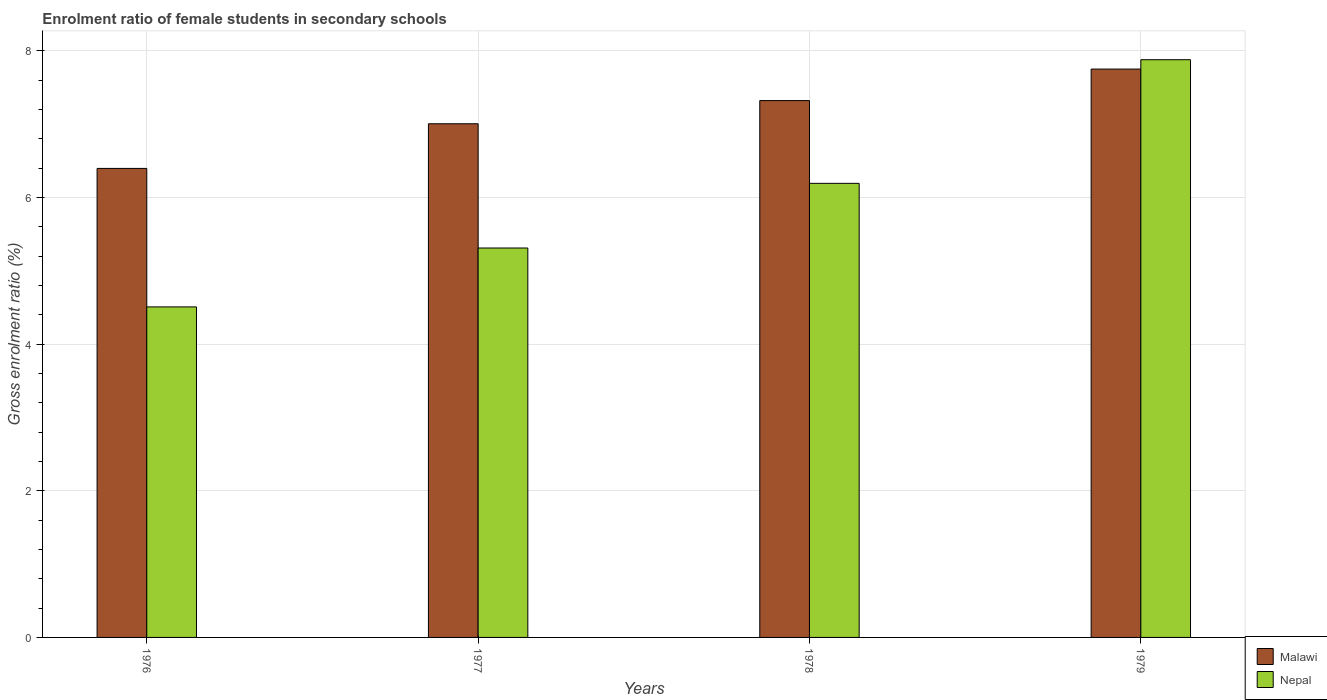How many different coloured bars are there?
Ensure brevity in your answer.  2. Are the number of bars on each tick of the X-axis equal?
Keep it short and to the point. Yes. How many bars are there on the 4th tick from the right?
Make the answer very short. 2. What is the label of the 3rd group of bars from the left?
Offer a very short reply. 1978. In how many cases, is the number of bars for a given year not equal to the number of legend labels?
Provide a short and direct response. 0. What is the enrolment ratio of female students in secondary schools in Nepal in 1978?
Your response must be concise. 6.19. Across all years, what is the maximum enrolment ratio of female students in secondary schools in Nepal?
Provide a succinct answer. 7.88. Across all years, what is the minimum enrolment ratio of female students in secondary schools in Nepal?
Offer a terse response. 4.51. In which year was the enrolment ratio of female students in secondary schools in Malawi maximum?
Ensure brevity in your answer.  1979. In which year was the enrolment ratio of female students in secondary schools in Nepal minimum?
Provide a succinct answer. 1976. What is the total enrolment ratio of female students in secondary schools in Malawi in the graph?
Your response must be concise. 28.48. What is the difference between the enrolment ratio of female students in secondary schools in Malawi in 1976 and that in 1978?
Ensure brevity in your answer.  -0.93. What is the difference between the enrolment ratio of female students in secondary schools in Nepal in 1978 and the enrolment ratio of female students in secondary schools in Malawi in 1979?
Offer a very short reply. -1.56. What is the average enrolment ratio of female students in secondary schools in Malawi per year?
Your response must be concise. 7.12. In the year 1978, what is the difference between the enrolment ratio of female students in secondary schools in Malawi and enrolment ratio of female students in secondary schools in Nepal?
Provide a succinct answer. 1.13. What is the ratio of the enrolment ratio of female students in secondary schools in Malawi in 1976 to that in 1977?
Make the answer very short. 0.91. What is the difference between the highest and the second highest enrolment ratio of female students in secondary schools in Nepal?
Give a very brief answer. 1.69. What is the difference between the highest and the lowest enrolment ratio of female students in secondary schools in Malawi?
Ensure brevity in your answer.  1.36. In how many years, is the enrolment ratio of female students in secondary schools in Nepal greater than the average enrolment ratio of female students in secondary schools in Nepal taken over all years?
Give a very brief answer. 2. Is the sum of the enrolment ratio of female students in secondary schools in Malawi in 1976 and 1979 greater than the maximum enrolment ratio of female students in secondary schools in Nepal across all years?
Give a very brief answer. Yes. What does the 2nd bar from the left in 1979 represents?
Provide a succinct answer. Nepal. What does the 1st bar from the right in 1977 represents?
Your answer should be very brief. Nepal. How many bars are there?
Provide a short and direct response. 8. Does the graph contain any zero values?
Your answer should be compact. No. Where does the legend appear in the graph?
Your response must be concise. Bottom right. How many legend labels are there?
Make the answer very short. 2. How are the legend labels stacked?
Your answer should be very brief. Vertical. What is the title of the graph?
Provide a short and direct response. Enrolment ratio of female students in secondary schools. What is the label or title of the X-axis?
Your response must be concise. Years. What is the label or title of the Y-axis?
Offer a terse response. Gross enrolment ratio (%). What is the Gross enrolment ratio (%) of Malawi in 1976?
Make the answer very short. 6.4. What is the Gross enrolment ratio (%) in Nepal in 1976?
Your response must be concise. 4.51. What is the Gross enrolment ratio (%) of Malawi in 1977?
Provide a short and direct response. 7.01. What is the Gross enrolment ratio (%) of Nepal in 1977?
Provide a succinct answer. 5.31. What is the Gross enrolment ratio (%) of Malawi in 1978?
Offer a terse response. 7.32. What is the Gross enrolment ratio (%) in Nepal in 1978?
Keep it short and to the point. 6.19. What is the Gross enrolment ratio (%) of Malawi in 1979?
Provide a short and direct response. 7.75. What is the Gross enrolment ratio (%) of Nepal in 1979?
Make the answer very short. 7.88. Across all years, what is the maximum Gross enrolment ratio (%) of Malawi?
Provide a short and direct response. 7.75. Across all years, what is the maximum Gross enrolment ratio (%) in Nepal?
Make the answer very short. 7.88. Across all years, what is the minimum Gross enrolment ratio (%) of Malawi?
Provide a succinct answer. 6.4. Across all years, what is the minimum Gross enrolment ratio (%) in Nepal?
Make the answer very short. 4.51. What is the total Gross enrolment ratio (%) of Malawi in the graph?
Give a very brief answer. 28.48. What is the total Gross enrolment ratio (%) of Nepal in the graph?
Keep it short and to the point. 23.9. What is the difference between the Gross enrolment ratio (%) of Malawi in 1976 and that in 1977?
Give a very brief answer. -0.61. What is the difference between the Gross enrolment ratio (%) of Nepal in 1976 and that in 1977?
Give a very brief answer. -0.8. What is the difference between the Gross enrolment ratio (%) in Malawi in 1976 and that in 1978?
Provide a succinct answer. -0.93. What is the difference between the Gross enrolment ratio (%) in Nepal in 1976 and that in 1978?
Offer a terse response. -1.69. What is the difference between the Gross enrolment ratio (%) of Malawi in 1976 and that in 1979?
Offer a terse response. -1.36. What is the difference between the Gross enrolment ratio (%) in Nepal in 1976 and that in 1979?
Give a very brief answer. -3.37. What is the difference between the Gross enrolment ratio (%) of Malawi in 1977 and that in 1978?
Provide a succinct answer. -0.32. What is the difference between the Gross enrolment ratio (%) in Nepal in 1977 and that in 1978?
Your answer should be very brief. -0.88. What is the difference between the Gross enrolment ratio (%) in Malawi in 1977 and that in 1979?
Offer a terse response. -0.75. What is the difference between the Gross enrolment ratio (%) of Nepal in 1977 and that in 1979?
Ensure brevity in your answer.  -2.57. What is the difference between the Gross enrolment ratio (%) of Malawi in 1978 and that in 1979?
Your answer should be very brief. -0.43. What is the difference between the Gross enrolment ratio (%) in Nepal in 1978 and that in 1979?
Your answer should be very brief. -1.69. What is the difference between the Gross enrolment ratio (%) in Malawi in 1976 and the Gross enrolment ratio (%) in Nepal in 1977?
Ensure brevity in your answer.  1.09. What is the difference between the Gross enrolment ratio (%) of Malawi in 1976 and the Gross enrolment ratio (%) of Nepal in 1978?
Offer a very short reply. 0.2. What is the difference between the Gross enrolment ratio (%) of Malawi in 1976 and the Gross enrolment ratio (%) of Nepal in 1979?
Your answer should be very brief. -1.48. What is the difference between the Gross enrolment ratio (%) of Malawi in 1977 and the Gross enrolment ratio (%) of Nepal in 1978?
Your response must be concise. 0.81. What is the difference between the Gross enrolment ratio (%) of Malawi in 1977 and the Gross enrolment ratio (%) of Nepal in 1979?
Give a very brief answer. -0.87. What is the difference between the Gross enrolment ratio (%) of Malawi in 1978 and the Gross enrolment ratio (%) of Nepal in 1979?
Make the answer very short. -0.56. What is the average Gross enrolment ratio (%) in Malawi per year?
Offer a terse response. 7.12. What is the average Gross enrolment ratio (%) in Nepal per year?
Provide a succinct answer. 5.97. In the year 1976, what is the difference between the Gross enrolment ratio (%) in Malawi and Gross enrolment ratio (%) in Nepal?
Your answer should be compact. 1.89. In the year 1977, what is the difference between the Gross enrolment ratio (%) in Malawi and Gross enrolment ratio (%) in Nepal?
Keep it short and to the point. 1.69. In the year 1978, what is the difference between the Gross enrolment ratio (%) in Malawi and Gross enrolment ratio (%) in Nepal?
Provide a short and direct response. 1.13. In the year 1979, what is the difference between the Gross enrolment ratio (%) of Malawi and Gross enrolment ratio (%) of Nepal?
Offer a very short reply. -0.13. What is the ratio of the Gross enrolment ratio (%) of Malawi in 1976 to that in 1977?
Your response must be concise. 0.91. What is the ratio of the Gross enrolment ratio (%) of Nepal in 1976 to that in 1977?
Your answer should be compact. 0.85. What is the ratio of the Gross enrolment ratio (%) of Malawi in 1976 to that in 1978?
Your answer should be compact. 0.87. What is the ratio of the Gross enrolment ratio (%) of Nepal in 1976 to that in 1978?
Provide a succinct answer. 0.73. What is the ratio of the Gross enrolment ratio (%) in Malawi in 1976 to that in 1979?
Offer a very short reply. 0.83. What is the ratio of the Gross enrolment ratio (%) in Nepal in 1976 to that in 1979?
Your answer should be compact. 0.57. What is the ratio of the Gross enrolment ratio (%) in Malawi in 1977 to that in 1978?
Make the answer very short. 0.96. What is the ratio of the Gross enrolment ratio (%) in Nepal in 1977 to that in 1978?
Your answer should be compact. 0.86. What is the ratio of the Gross enrolment ratio (%) in Malawi in 1977 to that in 1979?
Keep it short and to the point. 0.9. What is the ratio of the Gross enrolment ratio (%) in Nepal in 1977 to that in 1979?
Your answer should be compact. 0.67. What is the ratio of the Gross enrolment ratio (%) in Malawi in 1978 to that in 1979?
Provide a short and direct response. 0.94. What is the ratio of the Gross enrolment ratio (%) of Nepal in 1978 to that in 1979?
Offer a terse response. 0.79. What is the difference between the highest and the second highest Gross enrolment ratio (%) in Malawi?
Make the answer very short. 0.43. What is the difference between the highest and the second highest Gross enrolment ratio (%) in Nepal?
Your answer should be compact. 1.69. What is the difference between the highest and the lowest Gross enrolment ratio (%) of Malawi?
Give a very brief answer. 1.36. What is the difference between the highest and the lowest Gross enrolment ratio (%) in Nepal?
Keep it short and to the point. 3.37. 